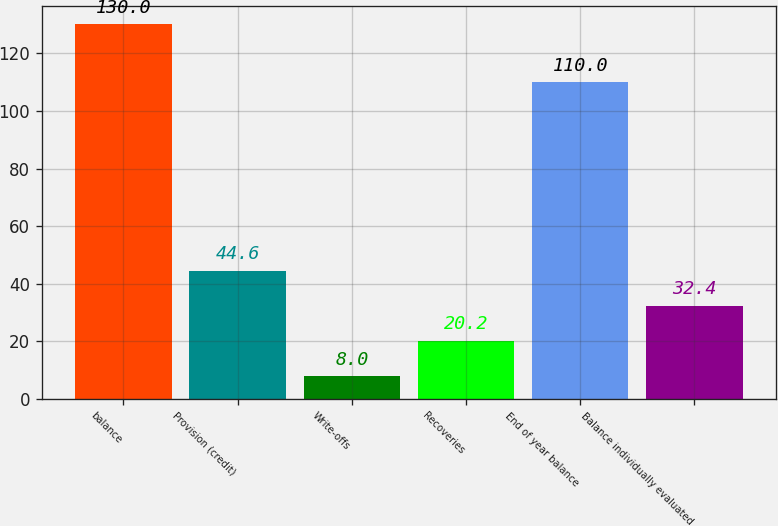Convert chart. <chart><loc_0><loc_0><loc_500><loc_500><bar_chart><fcel>balance<fcel>Provision (credit)<fcel>Write-offs<fcel>Recoveries<fcel>End of year balance<fcel>Balance individually evaluated<nl><fcel>130<fcel>44.6<fcel>8<fcel>20.2<fcel>110<fcel>32.4<nl></chart> 